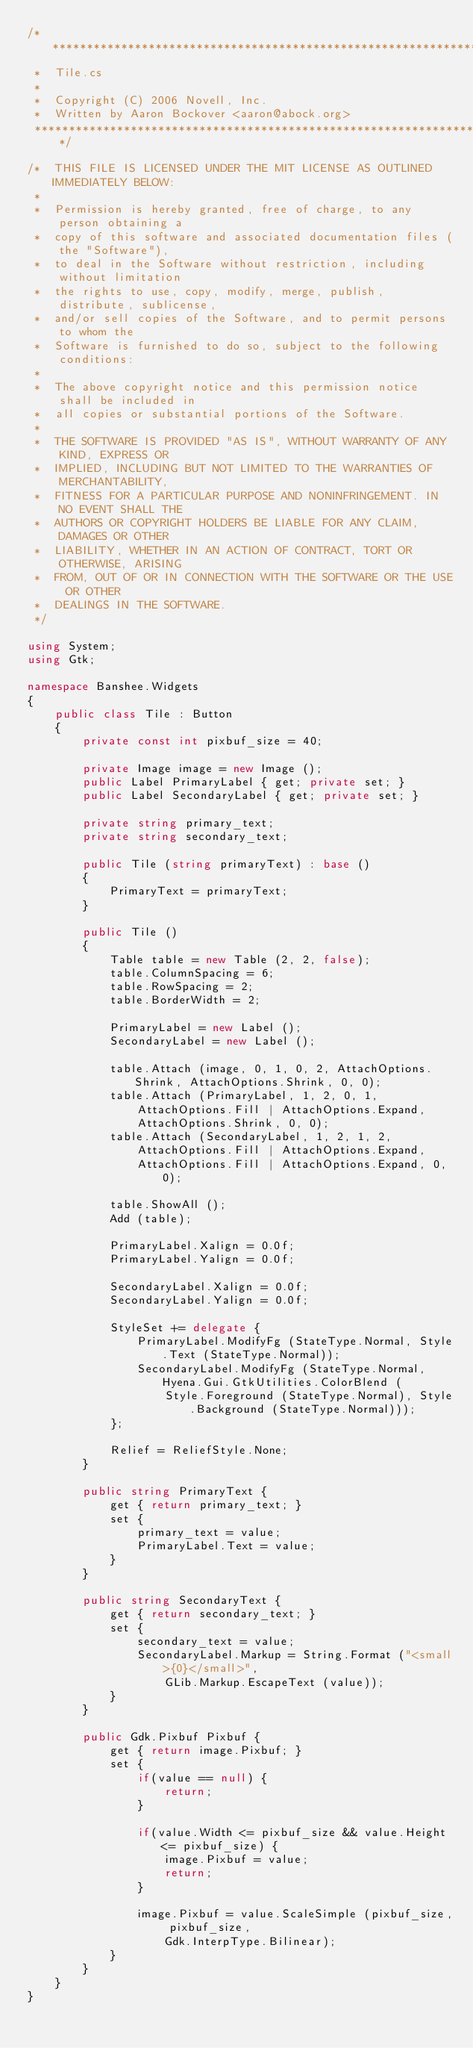<code> <loc_0><loc_0><loc_500><loc_500><_C#_>/***************************************************************************
 *  Tile.cs
 *
 *  Copyright (C) 2006 Novell, Inc.
 *  Written by Aaron Bockover <aaron@abock.org>
 ****************************************************************************/

/*  THIS FILE IS LICENSED UNDER THE MIT LICENSE AS OUTLINED IMMEDIATELY BELOW:
 *
 *  Permission is hereby granted, free of charge, to any person obtaining a
 *  copy of this software and associated documentation files (the "Software"),
 *  to deal in the Software without restriction, including without limitation
 *  the rights to use, copy, modify, merge, publish, distribute, sublicense,
 *  and/or sell copies of the Software, and to permit persons to whom the
 *  Software is furnished to do so, subject to the following conditions:
 *
 *  The above copyright notice and this permission notice shall be included in
 *  all copies or substantial portions of the Software.
 *
 *  THE SOFTWARE IS PROVIDED "AS IS", WITHOUT WARRANTY OF ANY KIND, EXPRESS OR
 *  IMPLIED, INCLUDING BUT NOT LIMITED TO THE WARRANTIES OF MERCHANTABILITY,
 *  FITNESS FOR A PARTICULAR PURPOSE AND NONINFRINGEMENT. IN NO EVENT SHALL THE
 *  AUTHORS OR COPYRIGHT HOLDERS BE LIABLE FOR ANY CLAIM, DAMAGES OR OTHER
 *  LIABILITY, WHETHER IN AN ACTION OF CONTRACT, TORT OR OTHERWISE, ARISING
 *  FROM, OUT OF OR IN CONNECTION WITH THE SOFTWARE OR THE USE OR OTHER
 *  DEALINGS IN THE SOFTWARE.
 */

using System;
using Gtk;

namespace Banshee.Widgets
{
    public class Tile : Button
    {
        private const int pixbuf_size = 40;

        private Image image = new Image ();
        public Label PrimaryLabel { get; private set; }
        public Label SecondaryLabel { get; private set; }

        private string primary_text;
        private string secondary_text;

        public Tile (string primaryText) : base ()
        {
            PrimaryText = primaryText;
        }

        public Tile ()
        {
            Table table = new Table (2, 2, false);
            table.ColumnSpacing = 6;
            table.RowSpacing = 2;
            table.BorderWidth = 2;

            PrimaryLabel = new Label ();
            SecondaryLabel = new Label ();

            table.Attach (image, 0, 1, 0, 2, AttachOptions.Shrink, AttachOptions.Shrink, 0, 0);
            table.Attach (PrimaryLabel, 1, 2, 0, 1,
                AttachOptions.Fill | AttachOptions.Expand,
                AttachOptions.Shrink, 0, 0);
            table.Attach (SecondaryLabel, 1, 2, 1, 2,
                AttachOptions.Fill | AttachOptions.Expand,
                AttachOptions.Fill | AttachOptions.Expand, 0, 0);

            table.ShowAll ();
            Add (table);

            PrimaryLabel.Xalign = 0.0f;
            PrimaryLabel.Yalign = 0.0f;

            SecondaryLabel.Xalign = 0.0f;
            SecondaryLabel.Yalign = 0.0f;

            StyleSet += delegate {
                PrimaryLabel.ModifyFg (StateType.Normal, Style.Text (StateType.Normal));
                SecondaryLabel.ModifyFg (StateType.Normal, Hyena.Gui.GtkUtilities.ColorBlend (
                    Style.Foreground (StateType.Normal), Style.Background (StateType.Normal)));
            };

            Relief = ReliefStyle.None;
        }

        public string PrimaryText {
            get { return primary_text; }
            set {
                primary_text = value;
                PrimaryLabel.Text = value;
            }
        }

        public string SecondaryText {
            get { return secondary_text; }
            set {
                secondary_text = value;
                SecondaryLabel.Markup = String.Format ("<small>{0}</small>",
                    GLib.Markup.EscapeText (value));
            }
        }

        public Gdk.Pixbuf Pixbuf {
            get { return image.Pixbuf; }
            set {
                if(value == null) {
                    return;
                }

                if(value.Width <= pixbuf_size && value.Height <= pixbuf_size) {
                    image.Pixbuf = value;
                    return;
                }

                image.Pixbuf = value.ScaleSimple (pixbuf_size, pixbuf_size,
                    Gdk.InterpType.Bilinear);
            }
        }
    }
}
</code> 